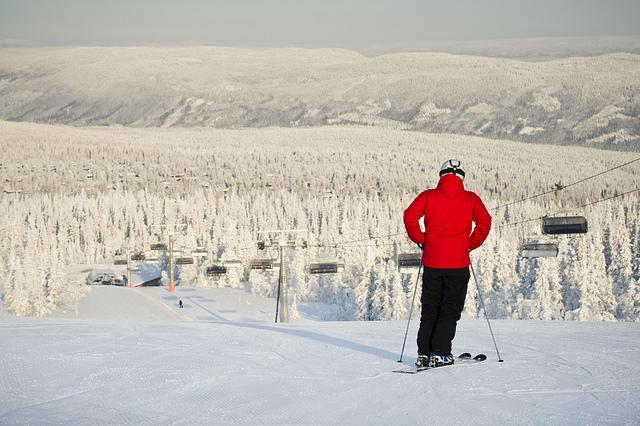What type of sport is he practicing?

Choices:
A) team
B) winter
C) aquatic
D) combat winter 